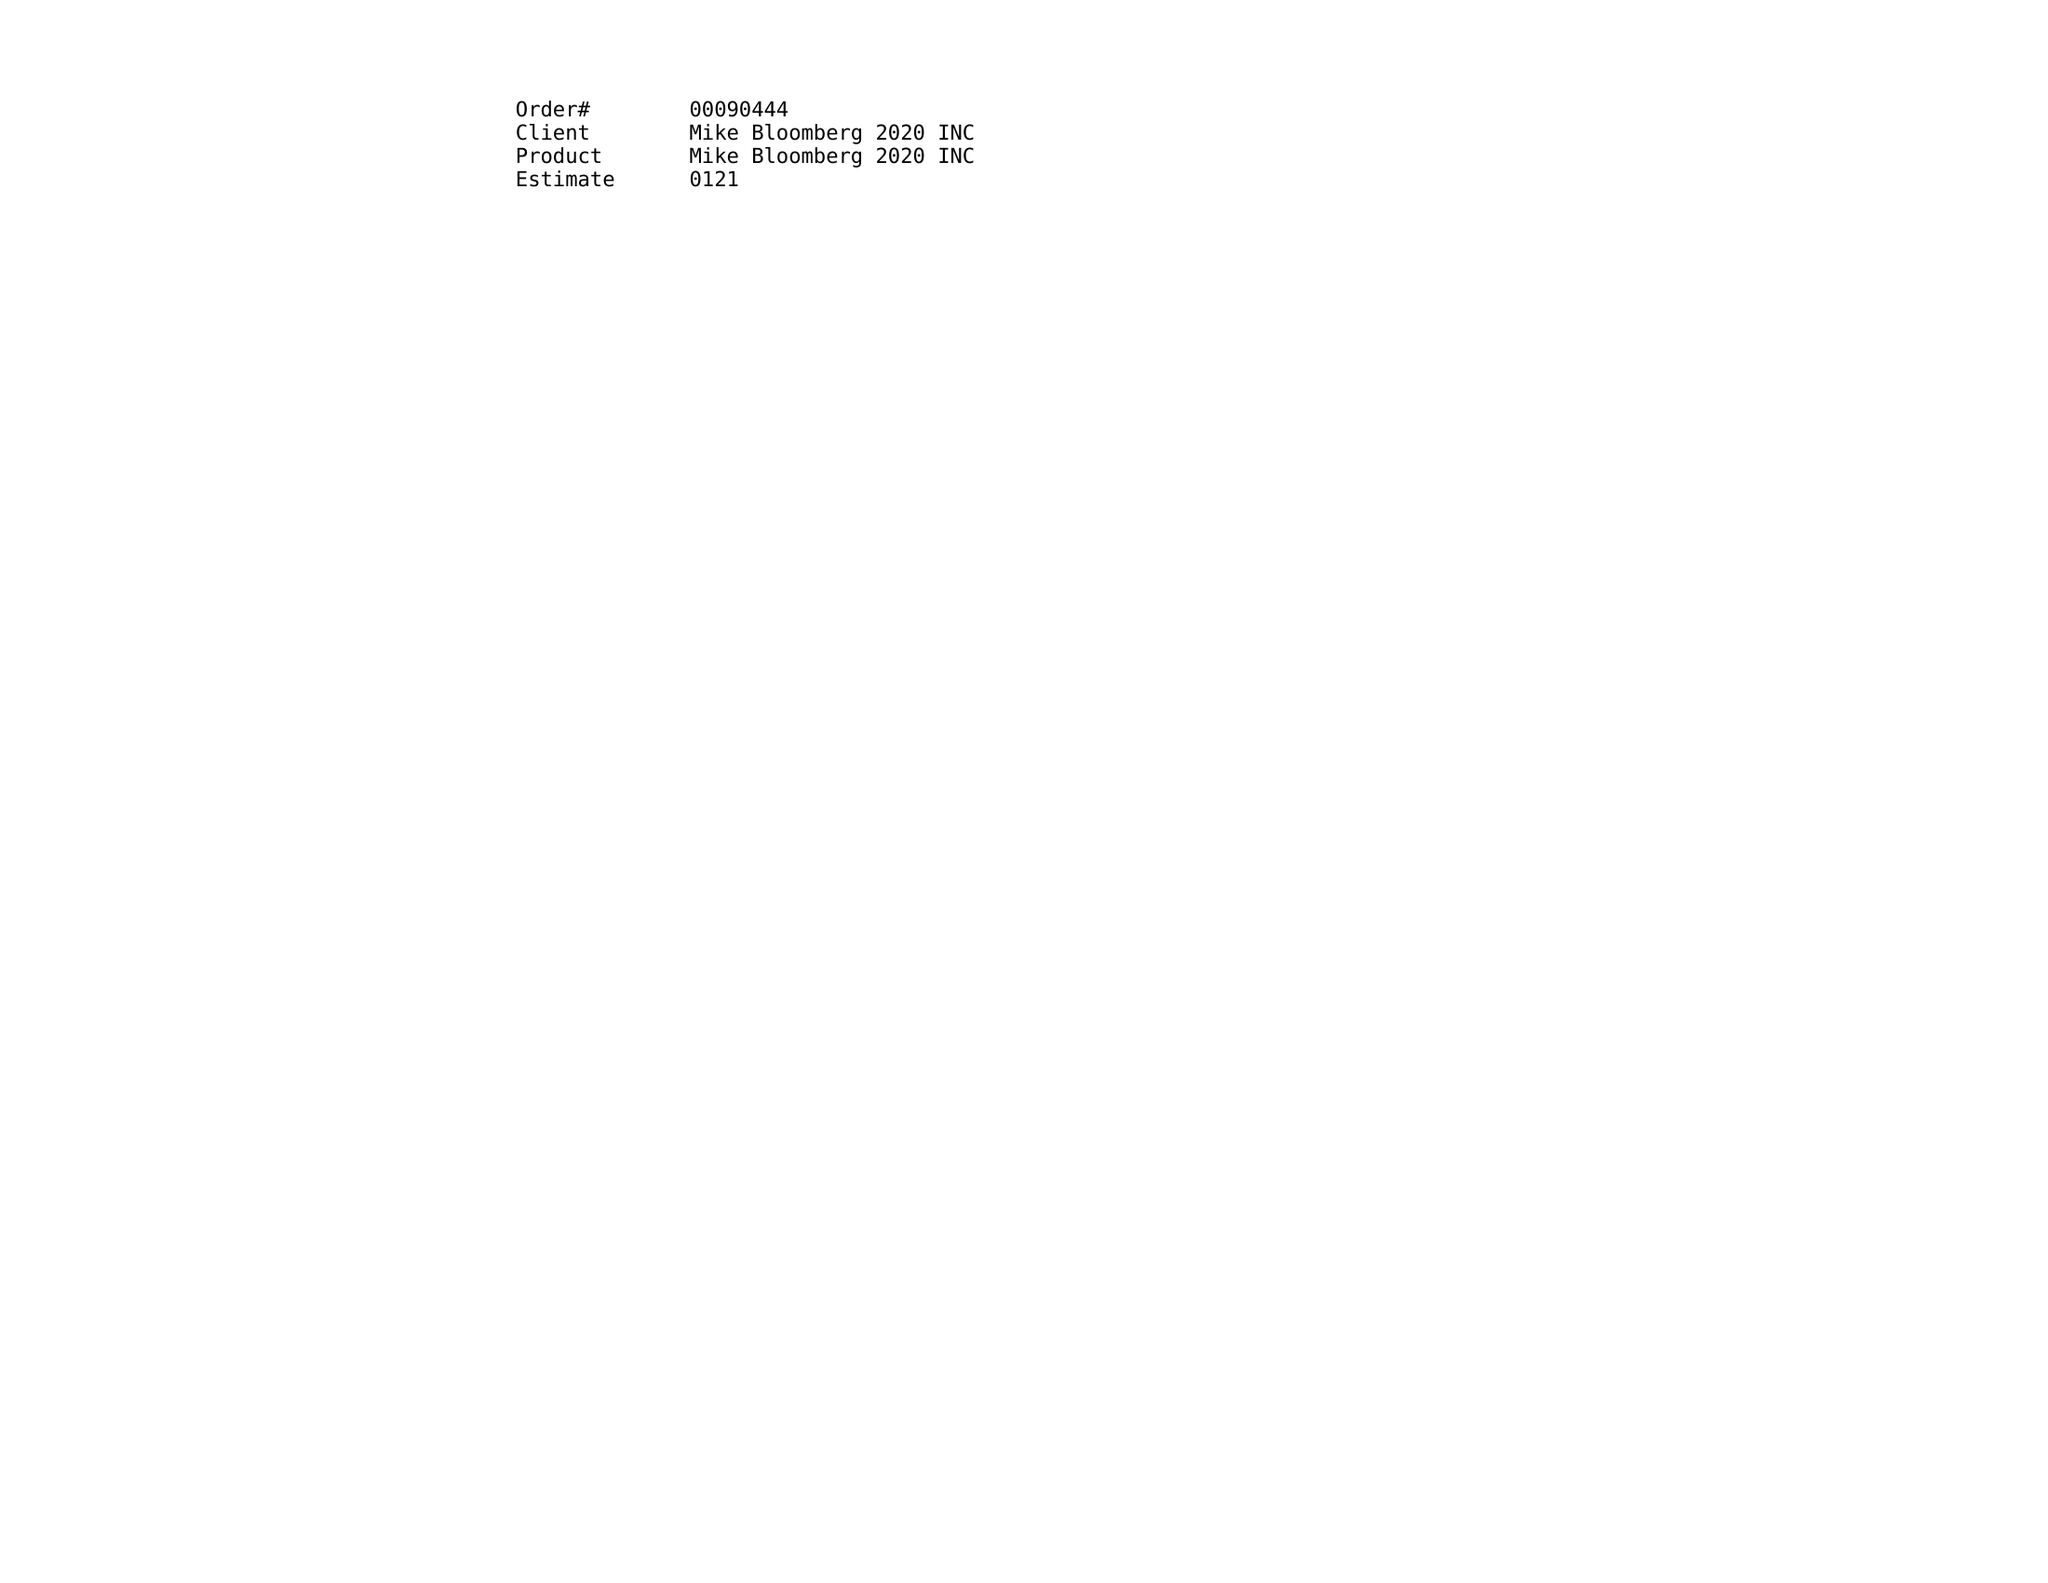What is the value for the flight_from?
Answer the question using a single word or phrase. 12/30/19 